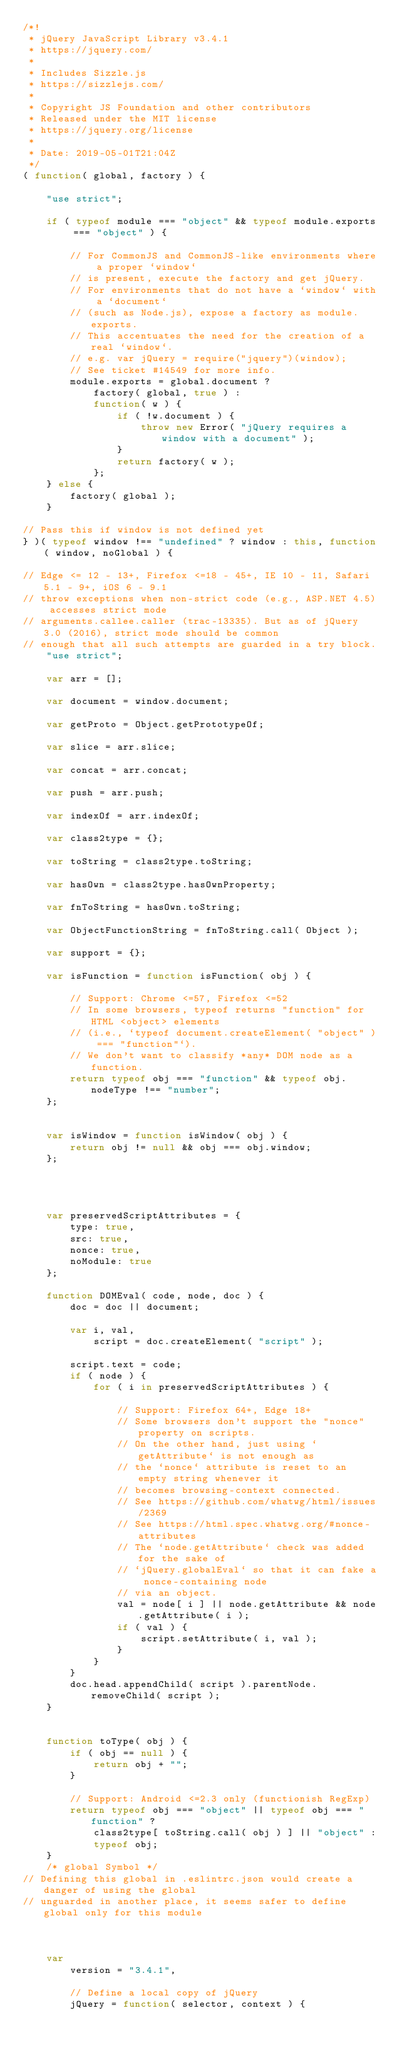<code> <loc_0><loc_0><loc_500><loc_500><_JavaScript_>/*!
 * jQuery JavaScript Library v3.4.1
 * https://jquery.com/
 *
 * Includes Sizzle.js
 * https://sizzlejs.com/
 *
 * Copyright JS Foundation and other contributors
 * Released under the MIT license
 * https://jquery.org/license
 *
 * Date: 2019-05-01T21:04Z
 */
( function( global, factory ) {

    "use strict";

    if ( typeof module === "object" && typeof module.exports === "object" ) {

        // For CommonJS and CommonJS-like environments where a proper `window`
        // is present, execute the factory and get jQuery.
        // For environments that do not have a `window` with a `document`
        // (such as Node.js), expose a factory as module.exports.
        // This accentuates the need for the creation of a real `window`.
        // e.g. var jQuery = require("jquery")(window);
        // See ticket #14549 for more info.
        module.exports = global.document ?
            factory( global, true ) :
            function( w ) {
                if ( !w.document ) {
                    throw new Error( "jQuery requires a window with a document" );
                }
                return factory( w );
            };
    } else {
        factory( global );
    }

// Pass this if window is not defined yet
} )( typeof window !== "undefined" ? window : this, function( window, noGlobal ) {

// Edge <= 12 - 13+, Firefox <=18 - 45+, IE 10 - 11, Safari 5.1 - 9+, iOS 6 - 9.1
// throw exceptions when non-strict code (e.g., ASP.NET 4.5) accesses strict mode
// arguments.callee.caller (trac-13335). But as of jQuery 3.0 (2016), strict mode should be common
// enough that all such attempts are guarded in a try block.
    "use strict";

    var arr = [];

    var document = window.document;

    var getProto = Object.getPrototypeOf;

    var slice = arr.slice;

    var concat = arr.concat;

    var push = arr.push;

    var indexOf = arr.indexOf;

    var class2type = {};

    var toString = class2type.toString;

    var hasOwn = class2type.hasOwnProperty;

    var fnToString = hasOwn.toString;

    var ObjectFunctionString = fnToString.call( Object );

    var support = {};

    var isFunction = function isFunction( obj ) {

        // Support: Chrome <=57, Firefox <=52
        // In some browsers, typeof returns "function" for HTML <object> elements
        // (i.e., `typeof document.createElement( "object" ) === "function"`).
        // We don't want to classify *any* DOM node as a function.
        return typeof obj === "function" && typeof obj.nodeType !== "number";
    };


    var isWindow = function isWindow( obj ) {
        return obj != null && obj === obj.window;
    };




    var preservedScriptAttributes = {
        type: true,
        src: true,
        nonce: true,
        noModule: true
    };

    function DOMEval( code, node, doc ) {
        doc = doc || document;

        var i, val,
            script = doc.createElement( "script" );

        script.text = code;
        if ( node ) {
            for ( i in preservedScriptAttributes ) {

                // Support: Firefox 64+, Edge 18+
                // Some browsers don't support the "nonce" property on scripts.
                // On the other hand, just using `getAttribute` is not enough as
                // the `nonce` attribute is reset to an empty string whenever it
                // becomes browsing-context connected.
                // See https://github.com/whatwg/html/issues/2369
                // See https://html.spec.whatwg.org/#nonce-attributes
                // The `node.getAttribute` check was added for the sake of
                // `jQuery.globalEval` so that it can fake a nonce-containing node
                // via an object.
                val = node[ i ] || node.getAttribute && node.getAttribute( i );
                if ( val ) {
                    script.setAttribute( i, val );
                }
            }
        }
        doc.head.appendChild( script ).parentNode.removeChild( script );
    }


    function toType( obj ) {
        if ( obj == null ) {
            return obj + "";
        }

        // Support: Android <=2.3 only (functionish RegExp)
        return typeof obj === "object" || typeof obj === "function" ?
            class2type[ toString.call( obj ) ] || "object" :
            typeof obj;
    }
    /* global Symbol */
// Defining this global in .eslintrc.json would create a danger of using the global
// unguarded in another place, it seems safer to define global only for this module



    var
        version = "3.4.1",

        // Define a local copy of jQuery
        jQuery = function( selector, context ) {
</code> 